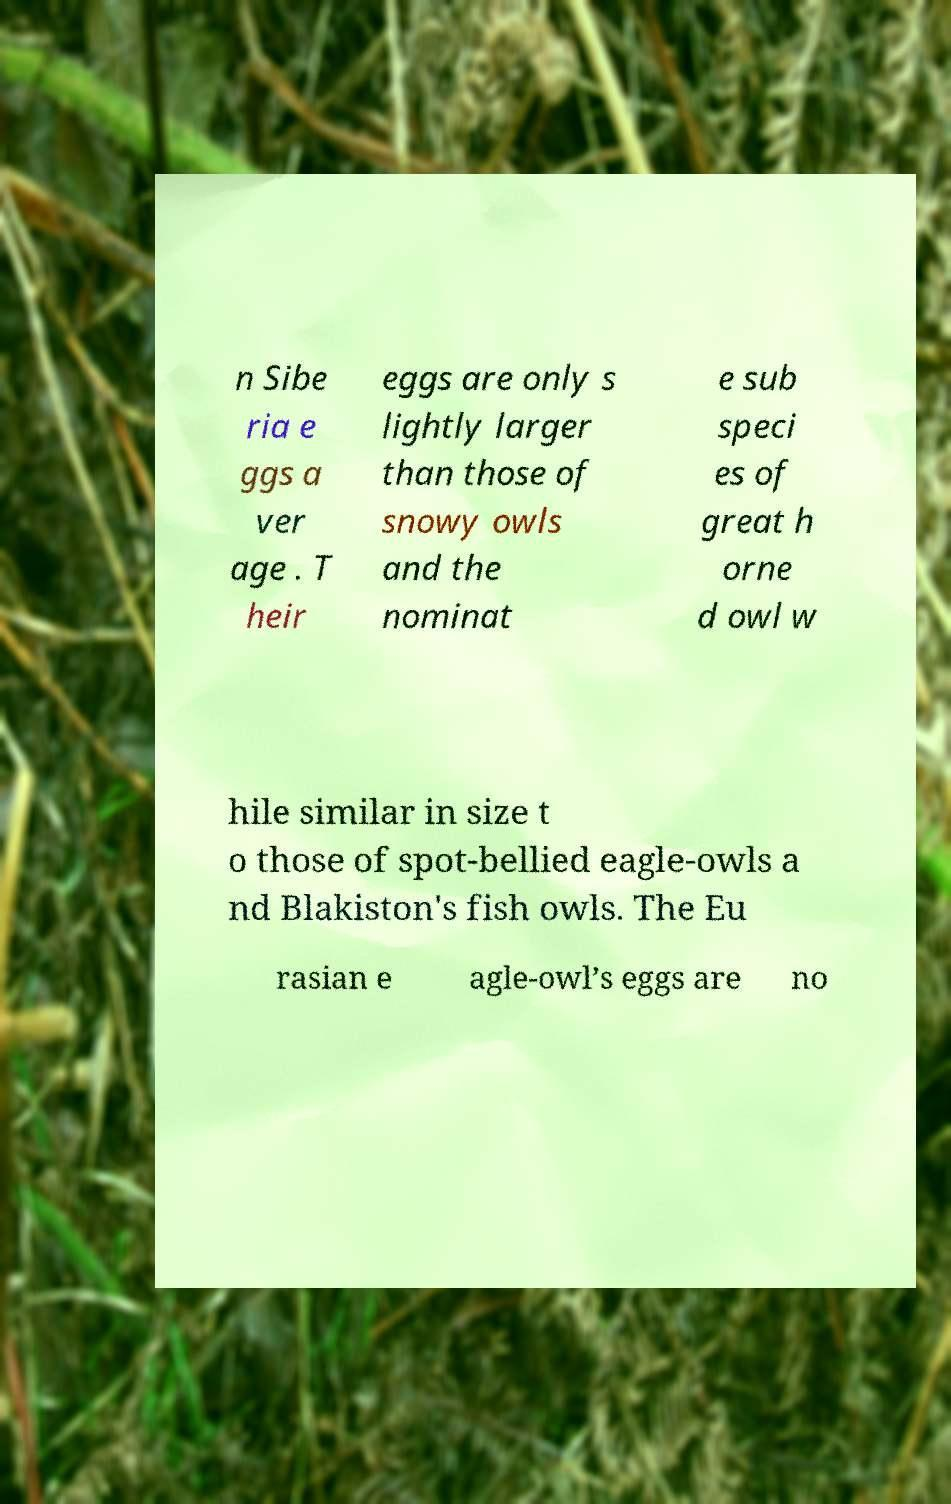There's text embedded in this image that I need extracted. Can you transcribe it verbatim? n Sibe ria e ggs a ver age . T heir eggs are only s lightly larger than those of snowy owls and the nominat e sub speci es of great h orne d owl w hile similar in size t o those of spot-bellied eagle-owls a nd Blakiston's fish owls. The Eu rasian e agle-owl’s eggs are no 